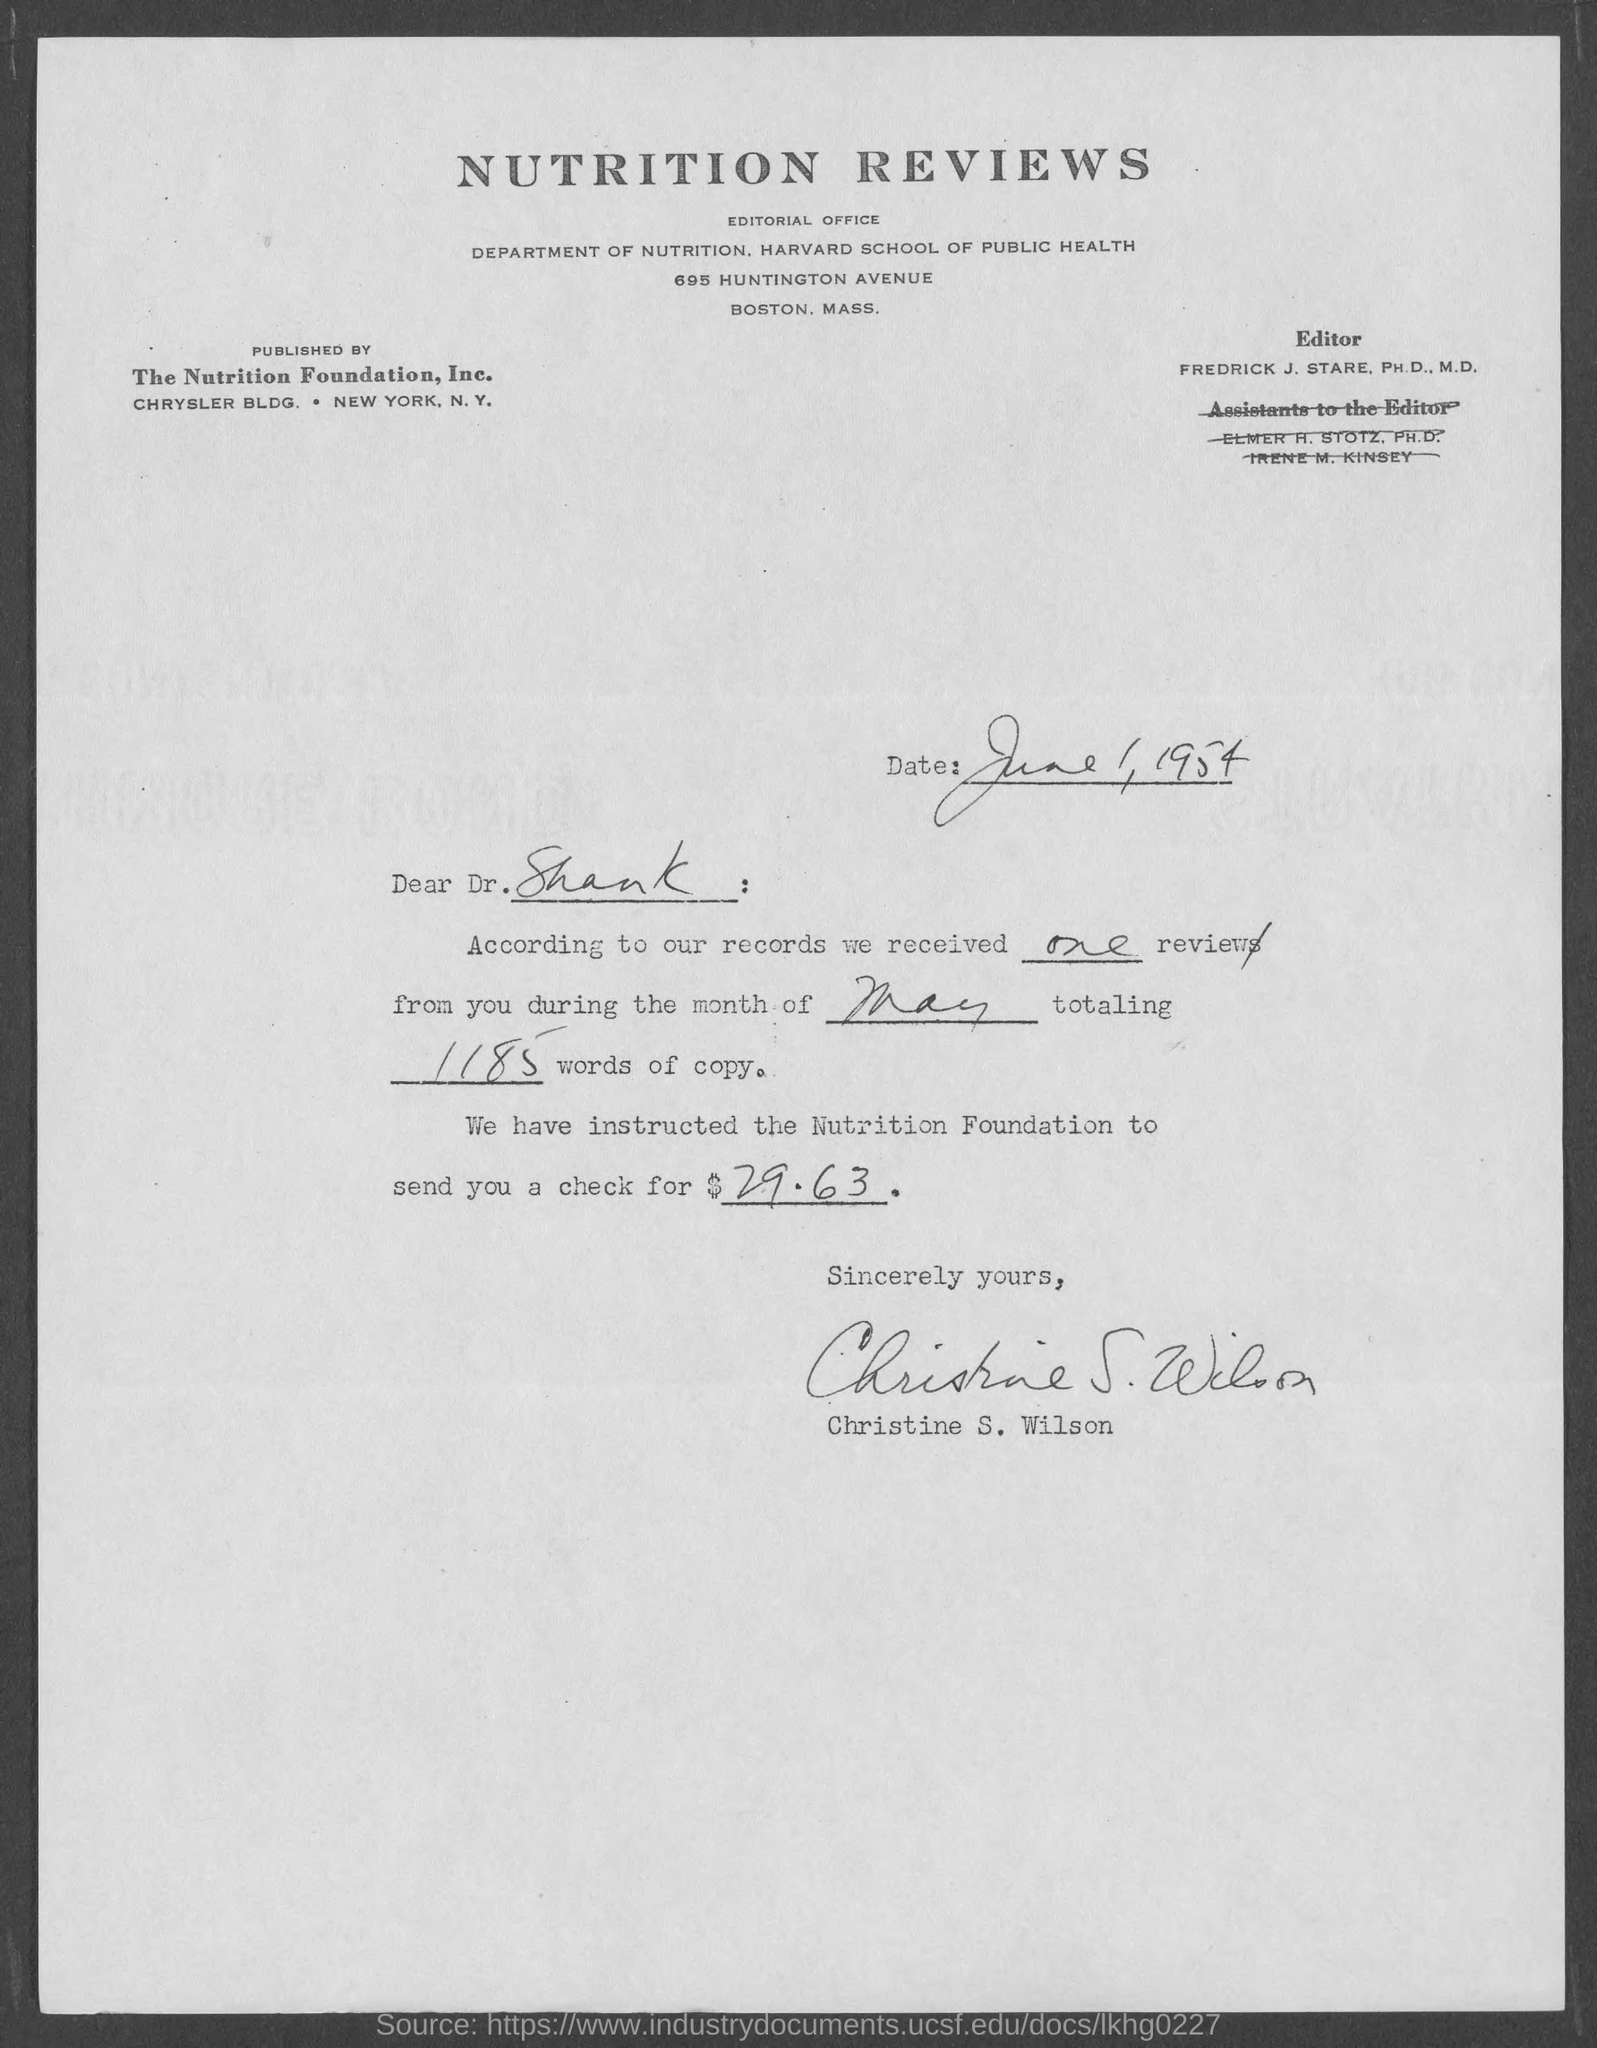What is the date mentioned in the given letter ?
Make the answer very short. June 1, 1954. According to our records how many reviews were received ?
Offer a terse response. One. During which month the reviews were received as mentioned in the given letter ?
Offer a terse response. May. Total how many words of copy are mentioned in the given letetr ?
Offer a terse response. 1185. What is the name of the editor mentioned in the given page ?
Make the answer very short. FREDRICK J. STARE. What is the name of the department mentioned in the given page ?
Offer a very short reply. Department of nutrition. By whom this letter was published ?
Your answer should be very brief. The nutrition foundation, Inc. 